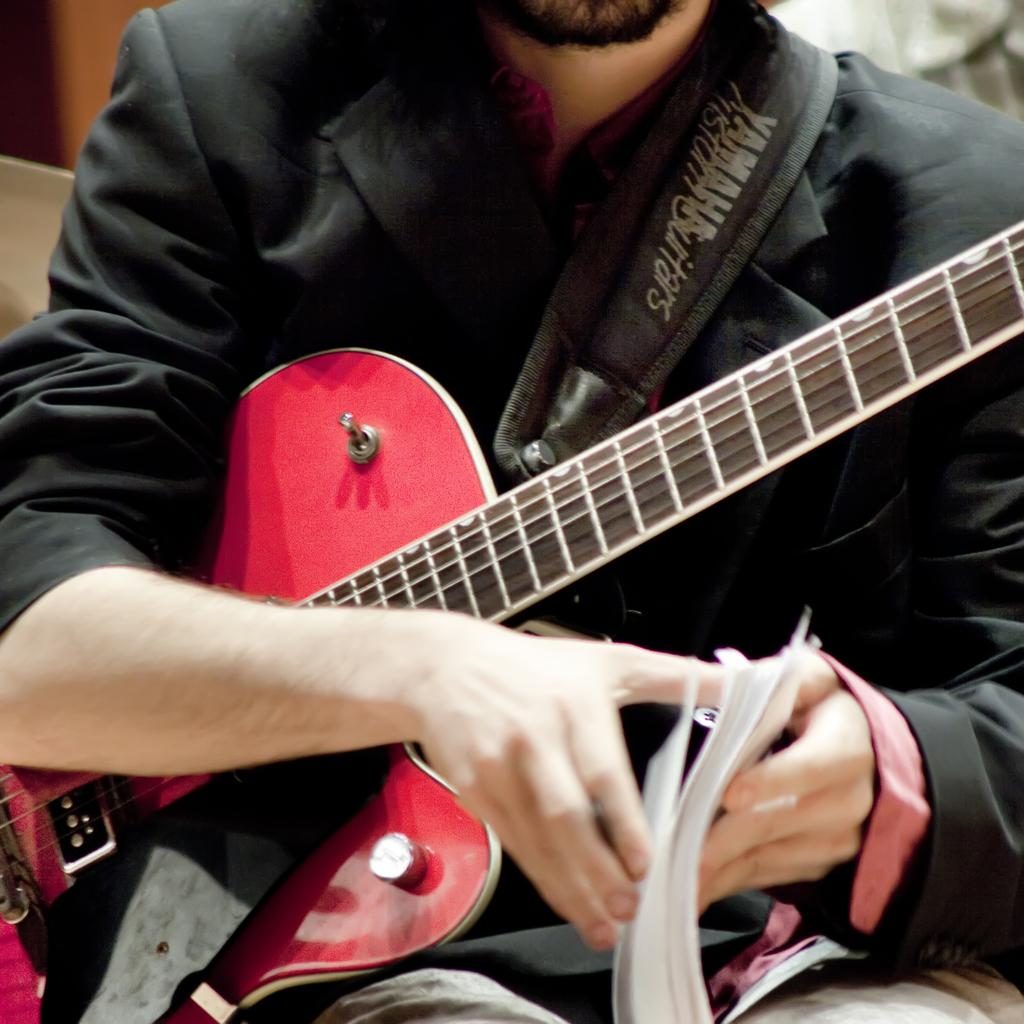What is the main subject of the image? There is a person in the image. What is the person holding in the image? The person is holding a guitar and a book. What type of ball is the person holding in the image? There is no ball present in the image; the person is holding a guitar and a book. 